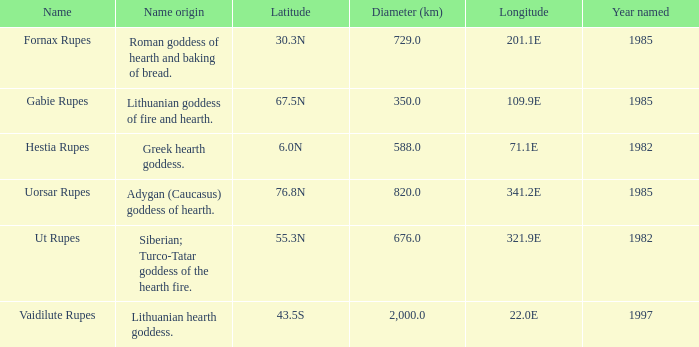At a latitude of 71.1e, what is the feature's name origin? Greek hearth goddess. 